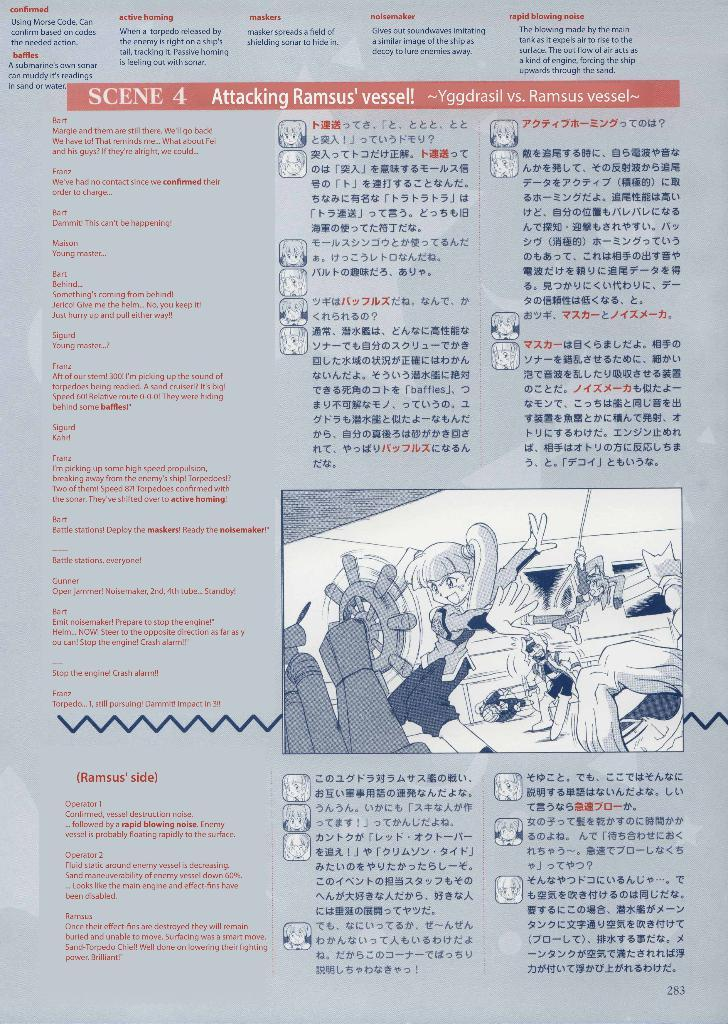<image>
Create a compact narrative representing the image presented. A translated page that is titled Attacking Ramsus' vessel! 